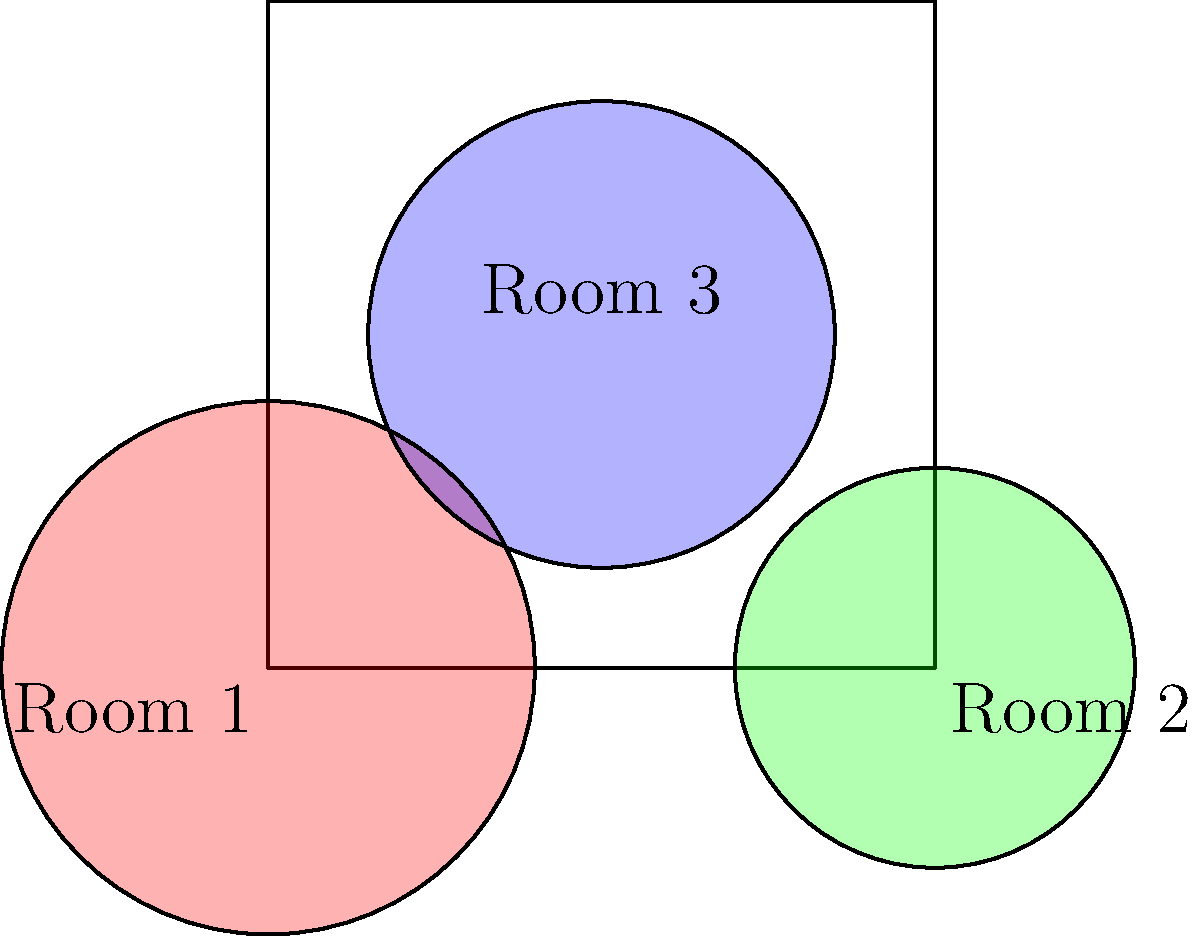In a multi-room massage facility, three different essential oils are diffused in three separate areas. The circles represent the zones of influence for each oil, with radii proportional to their strength. How many distinct aromatic zones are created within the facility, including areas with overlapping scents and areas with no scent? To solve this problem, we need to analyze the overlapping regions of the three circles representing the zones of influence for each essential oil. Let's break it down step-by-step:

1. First, identify the possible combinations of overlapping zones:
   - No overlap (areas outside all circles)
   - Single oil zones (areas within only one circle)
   - Two-oil overlap zones (areas where two circles intersect)
   - Three-oil overlap zone (area where all three circles intersect)

2. Count the distinct zones:
   a) No overlap zone: 1 (the area outside all circles)
   b) Single oil zones: 3 (one for each oil)
   c) Two-oil overlap zones: 3 (Room 1 & 2, Room 1 & 3, Room 2 & 3)
   d) Three-oil overlap zone: 1 (where all circles intersect)

3. Sum up all distinct zones:
   Total distinct zones = 1 + 3 + 3 + 1 = 8

Therefore, there are 8 distinct aromatic zones created within the facility, including areas with overlapping scents and areas with no scent.
Answer: 8 distinct aromatic zones 